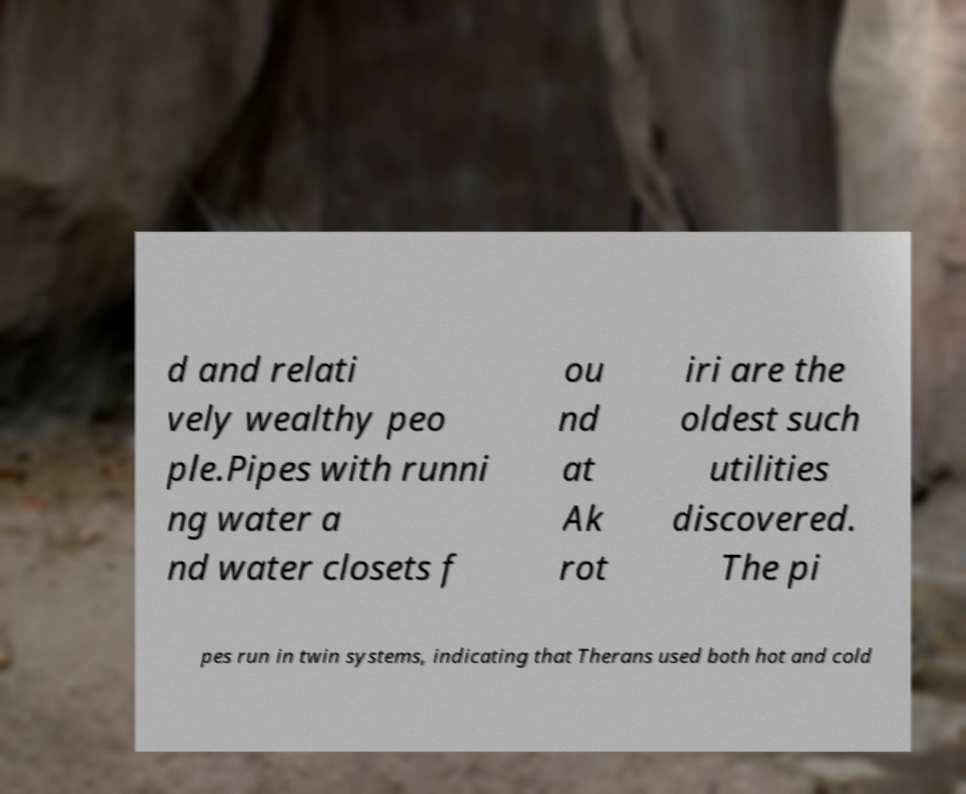Can you read and provide the text displayed in the image?This photo seems to have some interesting text. Can you extract and type it out for me? d and relati vely wealthy peo ple.Pipes with runni ng water a nd water closets f ou nd at Ak rot iri are the oldest such utilities discovered. The pi pes run in twin systems, indicating that Therans used both hot and cold 